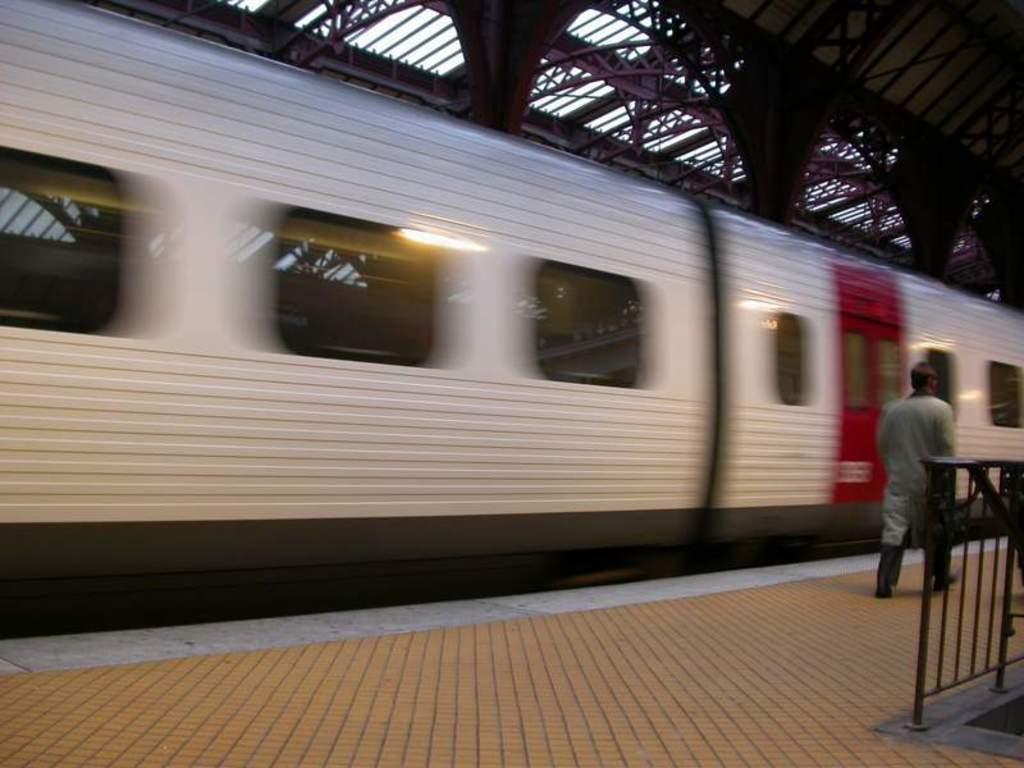What is the man in the image doing? There is a man walking on the platform in the image. What can be seen in the background of the image? There is a train in the image. What is the purpose of the fence in the image? The fence in the image serves as a barrier or boundary. What is visible at the top of the image? The sky is visible at the top of the image, and there are rods visible as well. What type of locket is the man wearing around his neck in the image? There is no locket visible around the man's neck in the image. How does the man's breath appear in the cold air in the image? The image does not show the man's breath, nor does it indicate the temperature of the air. 